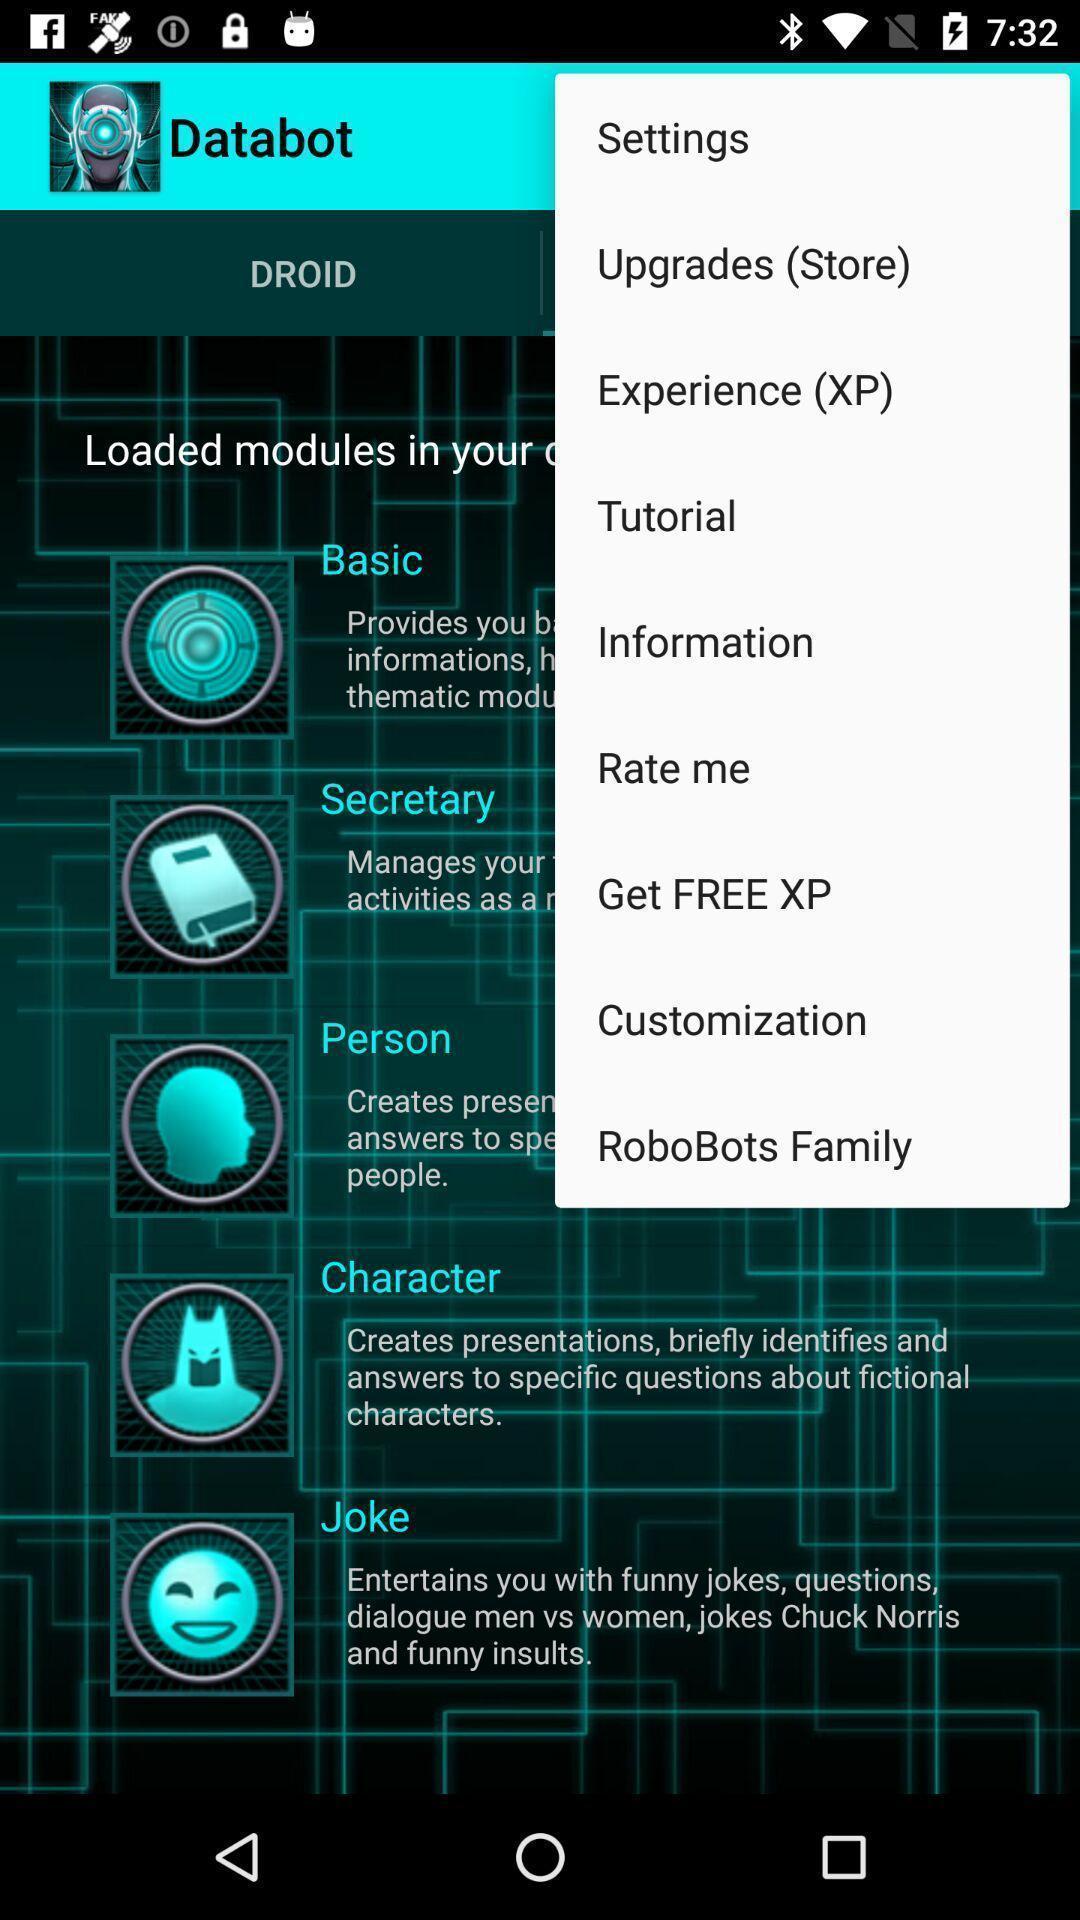Tell me what you see in this picture. Pop-up of options on a robot app. 